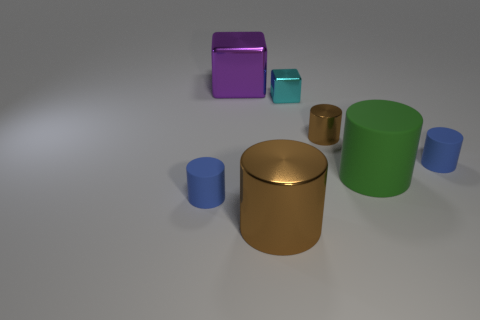Subtract all small brown shiny cylinders. How many cylinders are left? 4 Subtract 2 cylinders. How many cylinders are left? 3 Subtract all green cylinders. How many cylinders are left? 4 Subtract all cyan cylinders. Subtract all green spheres. How many cylinders are left? 5 Add 1 blue balls. How many objects exist? 8 Subtract all cubes. How many objects are left? 5 Add 3 metallic things. How many metallic things exist? 7 Subtract 0 blue spheres. How many objects are left? 7 Subtract all big red rubber balls. Subtract all tiny cyan objects. How many objects are left? 6 Add 6 green things. How many green things are left? 7 